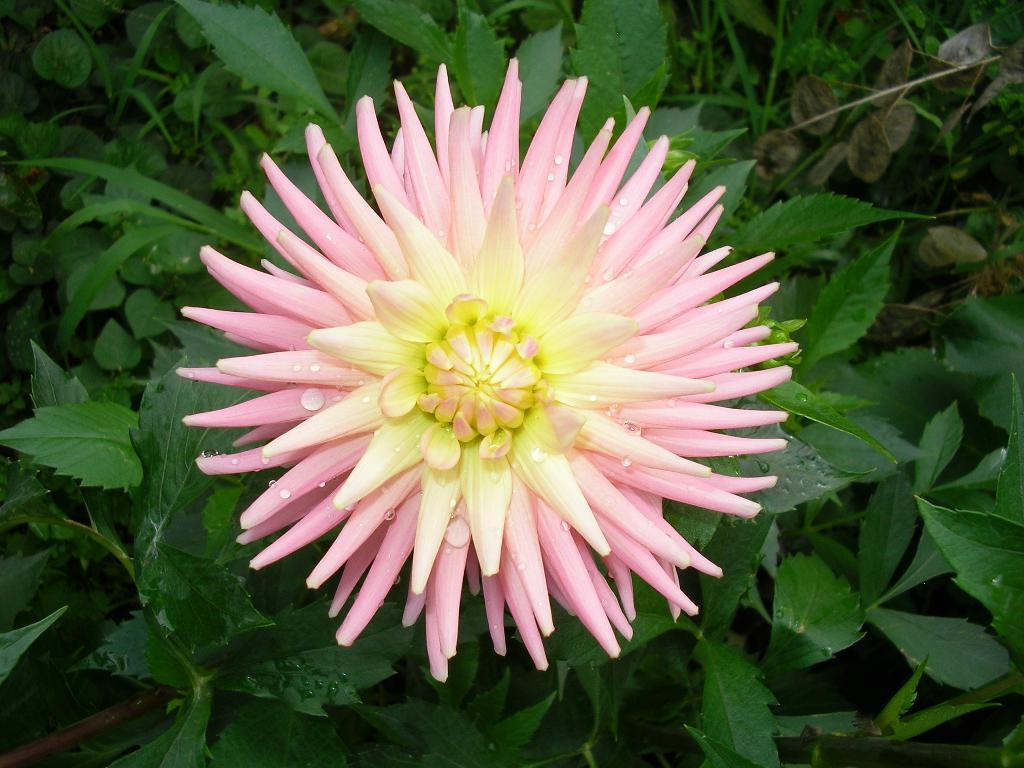What is the main subject of the image? There is a flower in the image. What can be observed on the flower? The flower has water drops on it. What type of vegetation is visible in the background of the image? There are green leaves in the background of the image. What else can be seen in the background of the image? There are stems visible in the background of the image. What type of gold spoon is lying next to the flower in the image? There is no gold spoon present in the image; it only features a flower with water drops and a background of green leaves and stems. 